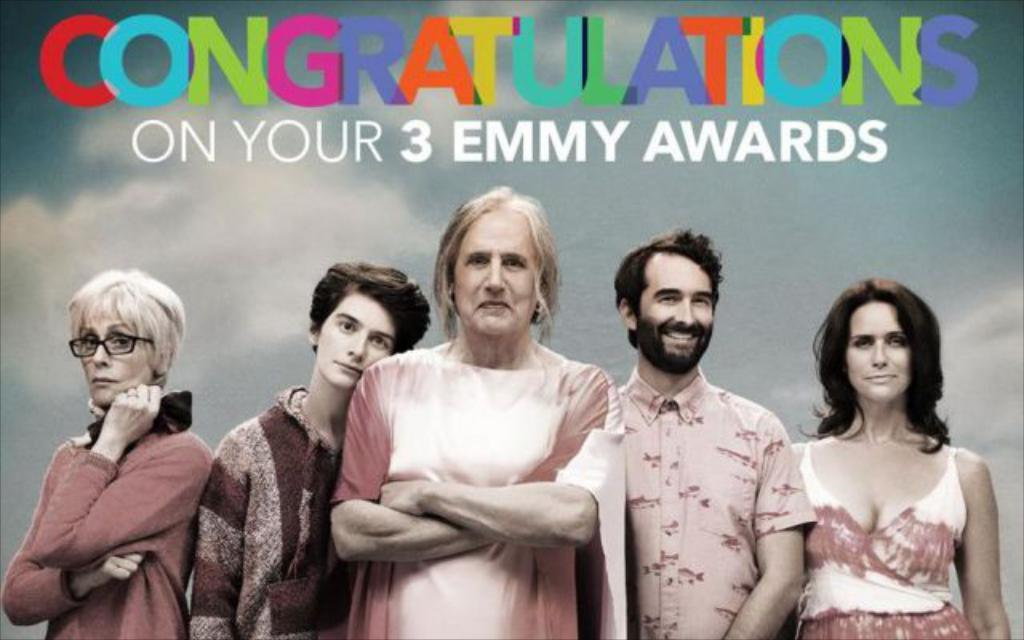What is the main subject of the image? There is a person standing in the center of the image. What can be seen in the background of the image? There is sky visible in the background of the image, and there are clouds present. Is there any text in the image? Yes, there is text at the top of the image. What type of chin can be seen on the person in the image? There is no chin visible in the image, as the person's face is not shown. Can you tell if the person in the image is feeling angry? The image does not provide any information about the person's emotions, so it cannot be determined if they are feeling angry. 